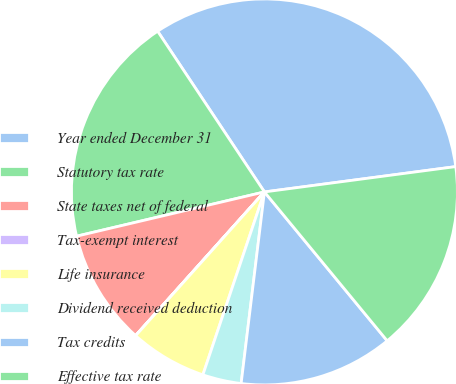Convert chart. <chart><loc_0><loc_0><loc_500><loc_500><pie_chart><fcel>Year ended December 31<fcel>Statutory tax rate<fcel>State taxes net of federal<fcel>Tax-exempt interest<fcel>Life insurance<fcel>Dividend received deduction<fcel>Tax credits<fcel>Effective tax rate<nl><fcel>32.24%<fcel>19.35%<fcel>9.68%<fcel>0.01%<fcel>6.46%<fcel>3.24%<fcel>12.9%<fcel>16.12%<nl></chart> 